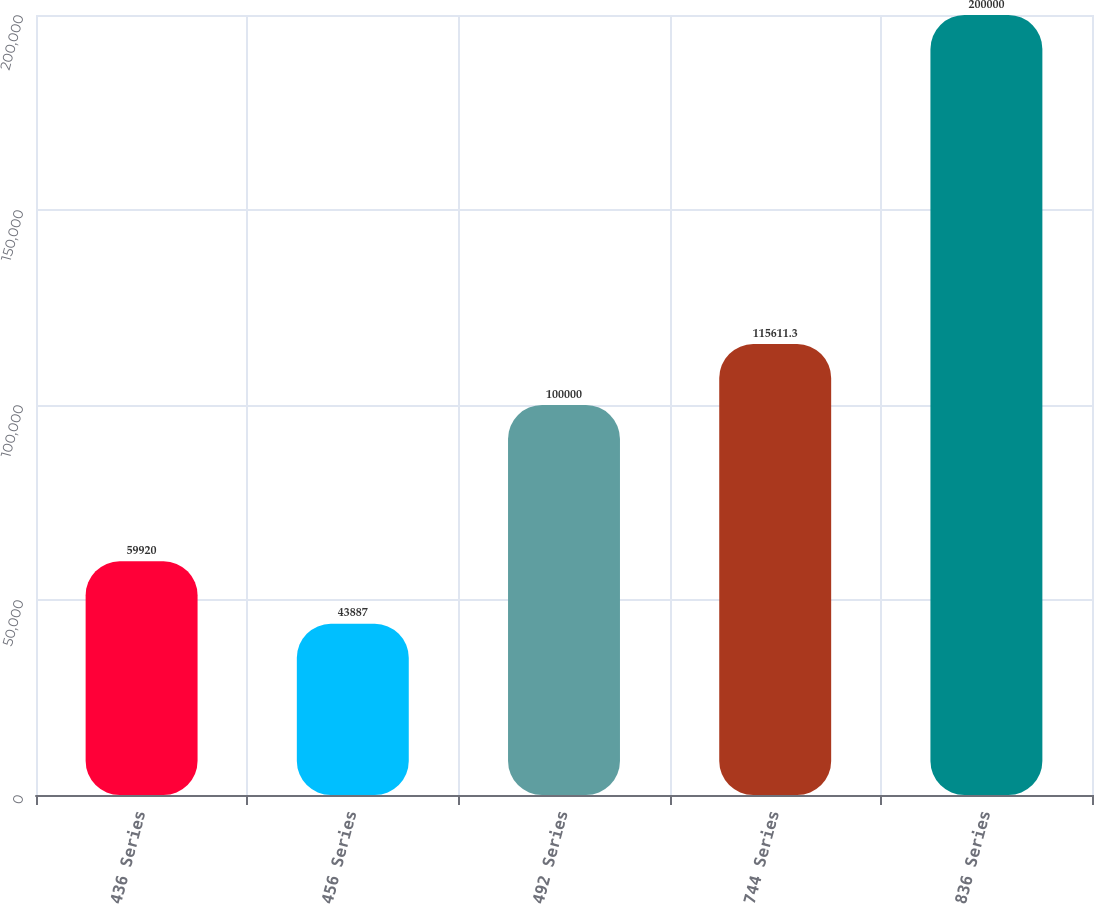<chart> <loc_0><loc_0><loc_500><loc_500><bar_chart><fcel>436 Series<fcel>456 Series<fcel>492 Series<fcel>744 Series<fcel>836 Series<nl><fcel>59920<fcel>43887<fcel>100000<fcel>115611<fcel>200000<nl></chart> 